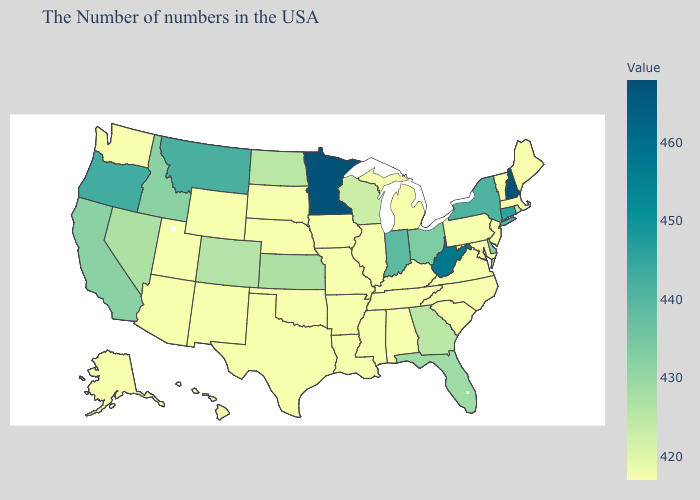Among the states that border Ohio , does Michigan have the lowest value?
Answer briefly. Yes. Does Nevada have the highest value in the USA?
Short answer required. No. Does West Virginia have the highest value in the South?
Answer briefly. Yes. Does the map have missing data?
Short answer required. No. 